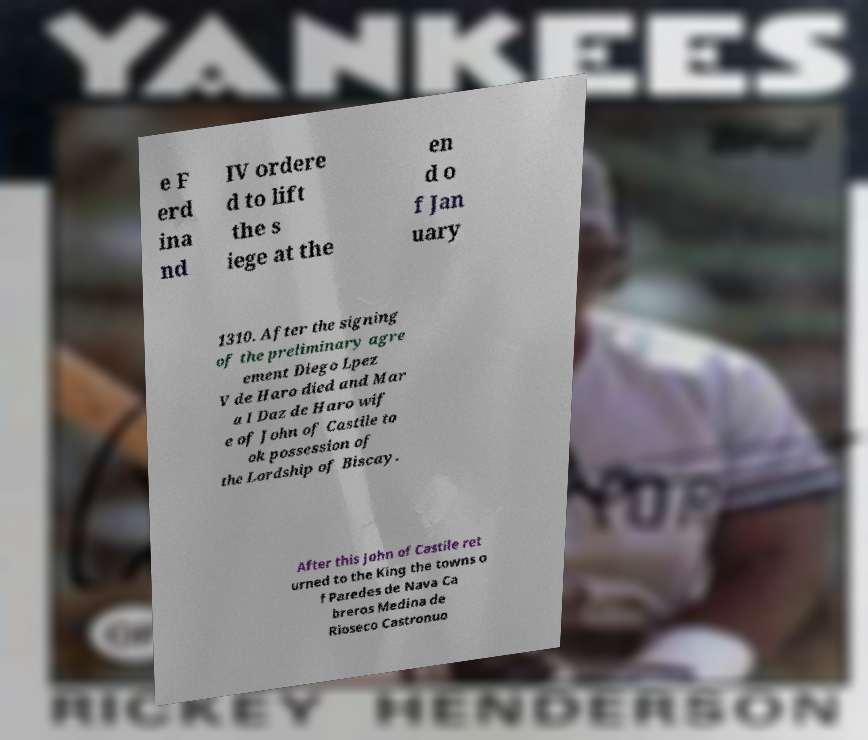I need the written content from this picture converted into text. Can you do that? e F erd ina nd IV ordere d to lift the s iege at the en d o f Jan uary 1310. After the signing of the preliminary agre ement Diego Lpez V de Haro died and Mar a I Daz de Haro wif e of John of Castile to ok possession of the Lordship of Biscay. After this John of Castile ret urned to the King the towns o f Paredes de Nava Ca breros Medina de Rioseco Castronuo 